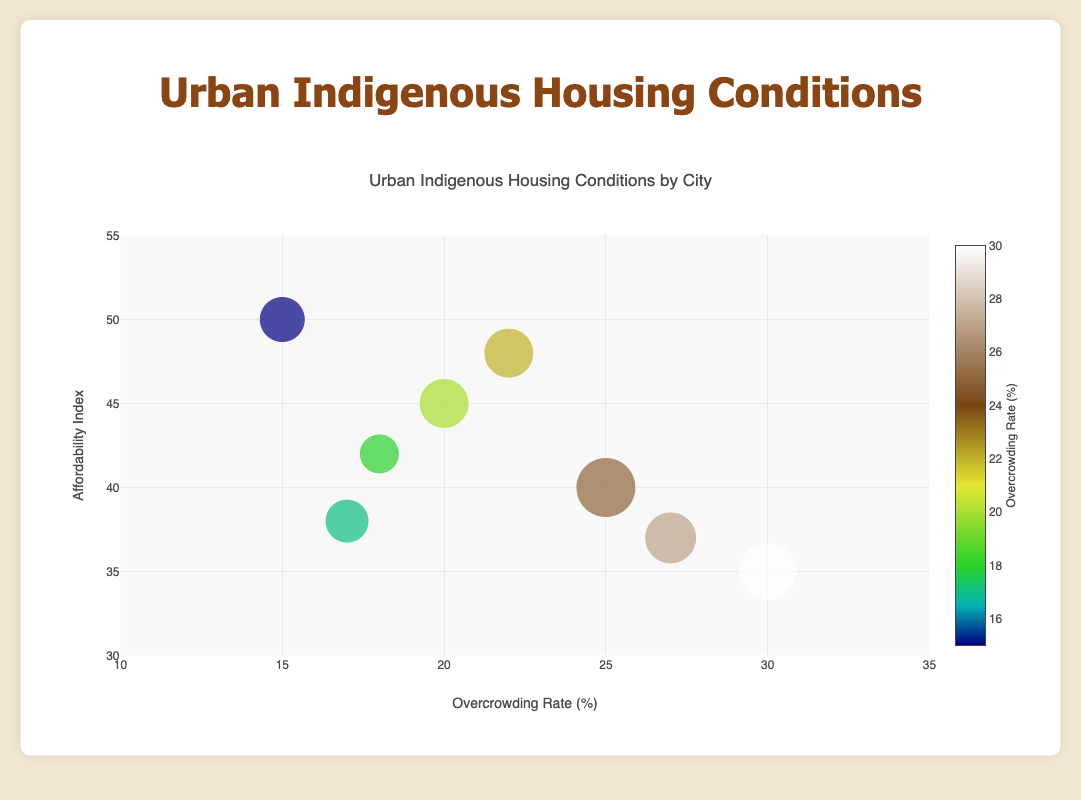What is the city with the highest overcrowding rate? Identify the city with the maximum value on the x-axis (overcrowding rate). The highest overcrowding rate is 30, associated with Vancouver.
Answer: Vancouver Which city has the highest affordability index? Find the city with the maximum value on the y-axis (affordability index). The highest affordability index is 50, associated with Calgary.
Answer: Calgary What is the affordability index of Winnipeg? Locate the data point representing Winnipeg, then read its y-axis value. The y-axis value for Winnipeg is 45.
Answer: 45 How does the size of the bubble correlate to the data? Examine the legend and markers. Bubble size correlates with a predefined `bubble_size` value representing each city's data. Larger bubbles indicate larger `bubble_size` values.
Answer: Bubble size correlates with the bubble_size value What city has the smallest bubble? Identify the city with the smallest bubble by visual inspection. The smallest bubble represents Montreal with a bubble size of 20.
Answer: Montreal Compare the overcrowding rate between Saskatoon and Ottawa. Which is higher? Locate both cities on the x-axis and compare their values. Saskatoon has an overcrowding rate of 27, while Ottawa's is 17. Saskatoon's overcrowding rate is higher.
Answer: Saskatoon Which city has the closest overcrowding rate to 20%? Find the city whose overcrowding rate is nearest to 20% on the x-axis. Winnipeg has an overcrowding rate exactly at 20%.
Answer: Winnipeg Rank Toronto, Vancouver, and Montreal in terms of affordability index from highest to lowest. Compare the y-axis values of these cities. Montreal is 42, Toronto is 40, and Vancouver is 35, so the order is Montreal, Toronto, then Vancouver.
Answer: Montreal, Toronto, Vancouver What's the average affordability index of Calgary, Edmonton, and Montreal? Sum the affordability indices of these three cities (50+48+42) and divide by 3. The average is (50+48+42)/3 = 46.67.
Answer: 46.67 Which city has a higher affordability index, Toronto or Ottawa? Compare their y-axis values. Toronto's affordability index is 40, and Ottawa's is 38. Toronto has a higher affordability index.
Answer: Toronto 